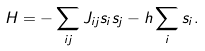Convert formula to latex. <formula><loc_0><loc_0><loc_500><loc_500>H = - \sum _ { i j } J _ { i j } s _ { i } s _ { j } - h \sum _ { i } s _ { i } .</formula> 